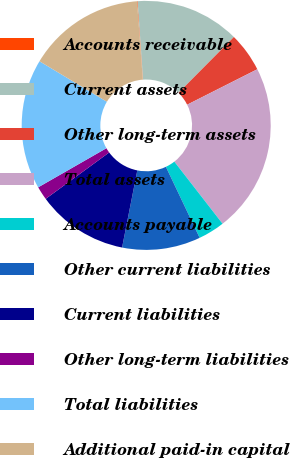Convert chart. <chart><loc_0><loc_0><loc_500><loc_500><pie_chart><fcel>Accounts receivable<fcel>Current assets<fcel>Other long-term assets<fcel>Total assets<fcel>Accounts payable<fcel>Other current liabilities<fcel>Current liabilities<fcel>Other long-term liabilities<fcel>Total liabilities<fcel>Additional paid-in capital<nl><fcel>0.08%<fcel>13.53%<fcel>5.12%<fcel>21.94%<fcel>3.44%<fcel>10.17%<fcel>11.85%<fcel>1.76%<fcel>16.9%<fcel>15.21%<nl></chart> 